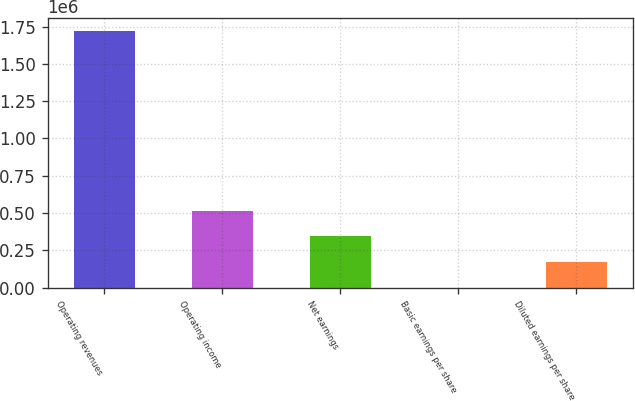Convert chart to OTSL. <chart><loc_0><loc_0><loc_500><loc_500><bar_chart><fcel>Operating revenues<fcel>Operating income<fcel>Net earnings<fcel>Basic earnings per share<fcel>Diluted earnings per share<nl><fcel>1.72106e+06<fcel>516319<fcel>344213<fcel>1.05<fcel>172107<nl></chart> 